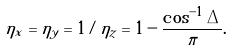Convert formula to latex. <formula><loc_0><loc_0><loc_500><loc_500>\eta _ { x } = \eta _ { y } = 1 / \eta _ { z } = 1 - \frac { \cos ^ { - 1 } \Delta } { \pi } .</formula> 